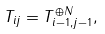<formula> <loc_0><loc_0><loc_500><loc_500>T _ { i j } = T _ { i - 1 , j - 1 } ^ { \oplus N } ,</formula> 